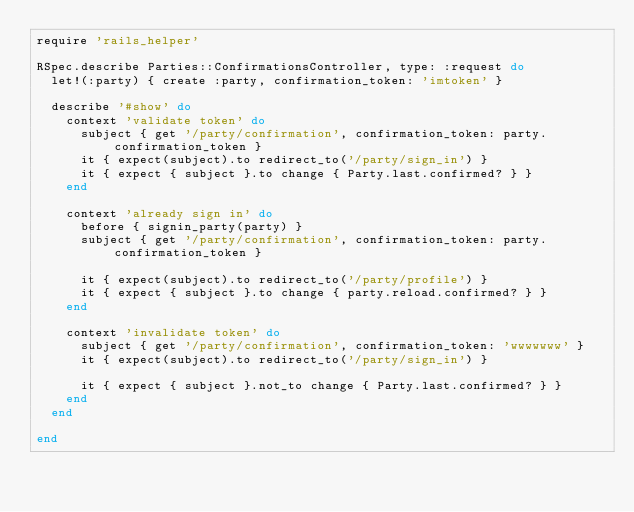Convert code to text. <code><loc_0><loc_0><loc_500><loc_500><_Ruby_>require 'rails_helper'

RSpec.describe Parties::ConfirmationsController, type: :request do
  let!(:party) { create :party, confirmation_token: 'imtoken' }

  describe '#show' do
    context 'validate token' do
      subject { get '/party/confirmation', confirmation_token: party.confirmation_token }
      it { expect(subject).to redirect_to('/party/sign_in') }
      it { expect { subject }.to change { Party.last.confirmed? } }
    end

    context 'already sign in' do
      before { signin_party(party) }
      subject { get '/party/confirmation', confirmation_token: party.confirmation_token }

      it { expect(subject).to redirect_to('/party/profile') }
      it { expect { subject }.to change { party.reload.confirmed? } }
    end

    context 'invalidate token' do
      subject { get '/party/confirmation', confirmation_token: 'wwwwwww' }
      it { expect(subject).to redirect_to('/party/sign_in') }

      it { expect { subject }.not_to change { Party.last.confirmed? } }
    end
  end

end
</code> 